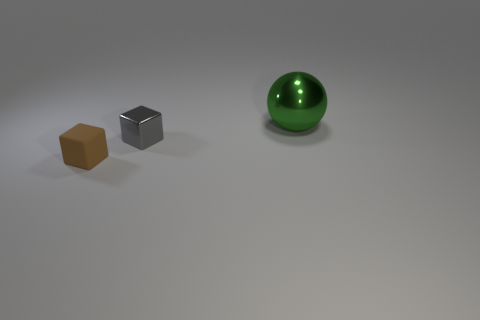What number of rubber blocks are in front of the small gray metallic block?
Make the answer very short. 1. Is the number of tiny gray things less than the number of large red shiny cylinders?
Give a very brief answer. No. Is the number of brown matte cubes that are behind the tiny rubber cube less than the number of big blue rubber things?
Provide a succinct answer. No. There is a small thing that is the same material as the green sphere; what shape is it?
Provide a short and direct response. Cube. Is the material of the big green thing the same as the small gray object?
Make the answer very short. Yes. Are there fewer gray metal things left of the small brown thing than small brown things left of the green thing?
Your response must be concise. Yes. How many tiny gray blocks are behind the small block that is to the left of the cube that is to the right of the matte thing?
Offer a very short reply. 1. What is the color of the thing that is the same size as the brown block?
Your answer should be compact. Gray. Is there another tiny metallic thing that has the same shape as the brown thing?
Provide a short and direct response. Yes. Are there any small things that are left of the shiny thing in front of the metallic thing behind the gray block?
Make the answer very short. Yes. 